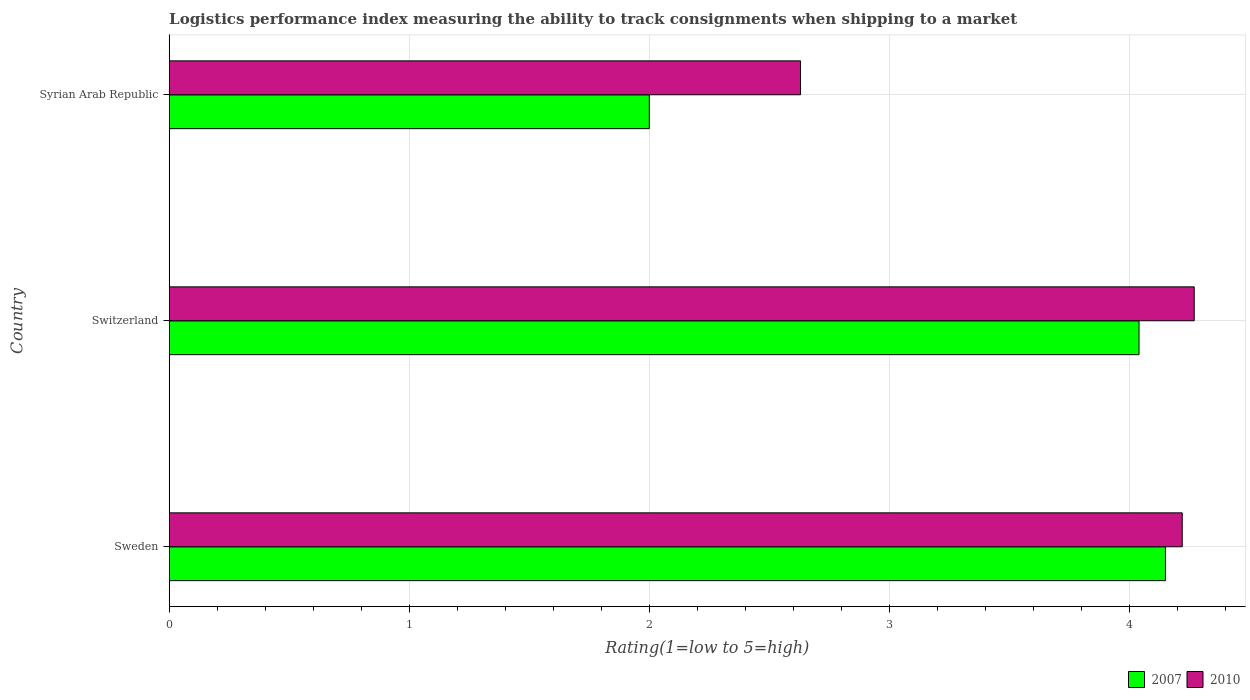How many groups of bars are there?
Your response must be concise. 3. Are the number of bars on each tick of the Y-axis equal?
Provide a succinct answer. Yes. How many bars are there on the 3rd tick from the top?
Provide a succinct answer. 2. How many bars are there on the 1st tick from the bottom?
Make the answer very short. 2. What is the label of the 3rd group of bars from the top?
Ensure brevity in your answer.  Sweden. Across all countries, what is the maximum Logistic performance index in 2010?
Your response must be concise. 4.27. Across all countries, what is the minimum Logistic performance index in 2007?
Provide a succinct answer. 2. In which country was the Logistic performance index in 2007 maximum?
Keep it short and to the point. Sweden. In which country was the Logistic performance index in 2007 minimum?
Your response must be concise. Syrian Arab Republic. What is the total Logistic performance index in 2010 in the graph?
Provide a succinct answer. 11.12. What is the difference between the Logistic performance index in 2007 in Sweden and that in Syrian Arab Republic?
Make the answer very short. 2.15. What is the difference between the Logistic performance index in 2010 in Syrian Arab Republic and the Logistic performance index in 2007 in Sweden?
Give a very brief answer. -1.52. What is the average Logistic performance index in 2010 per country?
Give a very brief answer. 3.71. What is the difference between the Logistic performance index in 2010 and Logistic performance index in 2007 in Syrian Arab Republic?
Your answer should be compact. 0.63. In how many countries, is the Logistic performance index in 2007 greater than 2.8 ?
Give a very brief answer. 2. What is the ratio of the Logistic performance index in 2010 in Switzerland to that in Syrian Arab Republic?
Your response must be concise. 1.62. Is the difference between the Logistic performance index in 2010 in Sweden and Syrian Arab Republic greater than the difference between the Logistic performance index in 2007 in Sweden and Syrian Arab Republic?
Offer a very short reply. No. What is the difference between the highest and the second highest Logistic performance index in 2010?
Give a very brief answer. 0.05. What is the difference between the highest and the lowest Logistic performance index in 2007?
Your answer should be very brief. 2.15. In how many countries, is the Logistic performance index in 2010 greater than the average Logistic performance index in 2010 taken over all countries?
Your answer should be compact. 2. Is the sum of the Logistic performance index in 2007 in Sweden and Syrian Arab Republic greater than the maximum Logistic performance index in 2010 across all countries?
Provide a succinct answer. Yes. What does the 1st bar from the top in Switzerland represents?
Your answer should be compact. 2010. What does the 2nd bar from the bottom in Syrian Arab Republic represents?
Make the answer very short. 2010. How many legend labels are there?
Provide a succinct answer. 2. What is the title of the graph?
Your answer should be very brief. Logistics performance index measuring the ability to track consignments when shipping to a market. What is the label or title of the X-axis?
Keep it short and to the point. Rating(1=low to 5=high). What is the label or title of the Y-axis?
Your response must be concise. Country. What is the Rating(1=low to 5=high) in 2007 in Sweden?
Keep it short and to the point. 4.15. What is the Rating(1=low to 5=high) in 2010 in Sweden?
Provide a succinct answer. 4.22. What is the Rating(1=low to 5=high) of 2007 in Switzerland?
Provide a succinct answer. 4.04. What is the Rating(1=low to 5=high) in 2010 in Switzerland?
Offer a very short reply. 4.27. What is the Rating(1=low to 5=high) in 2010 in Syrian Arab Republic?
Provide a short and direct response. 2.63. Across all countries, what is the maximum Rating(1=low to 5=high) in 2007?
Your response must be concise. 4.15. Across all countries, what is the maximum Rating(1=low to 5=high) of 2010?
Your response must be concise. 4.27. Across all countries, what is the minimum Rating(1=low to 5=high) of 2007?
Give a very brief answer. 2. Across all countries, what is the minimum Rating(1=low to 5=high) in 2010?
Offer a very short reply. 2.63. What is the total Rating(1=low to 5=high) of 2007 in the graph?
Offer a terse response. 10.19. What is the total Rating(1=low to 5=high) of 2010 in the graph?
Your response must be concise. 11.12. What is the difference between the Rating(1=low to 5=high) in 2007 in Sweden and that in Switzerland?
Provide a succinct answer. 0.11. What is the difference between the Rating(1=low to 5=high) in 2007 in Sweden and that in Syrian Arab Republic?
Keep it short and to the point. 2.15. What is the difference between the Rating(1=low to 5=high) in 2010 in Sweden and that in Syrian Arab Republic?
Provide a succinct answer. 1.59. What is the difference between the Rating(1=low to 5=high) of 2007 in Switzerland and that in Syrian Arab Republic?
Ensure brevity in your answer.  2.04. What is the difference between the Rating(1=low to 5=high) in 2010 in Switzerland and that in Syrian Arab Republic?
Make the answer very short. 1.64. What is the difference between the Rating(1=low to 5=high) of 2007 in Sweden and the Rating(1=low to 5=high) of 2010 in Switzerland?
Provide a short and direct response. -0.12. What is the difference between the Rating(1=low to 5=high) in 2007 in Sweden and the Rating(1=low to 5=high) in 2010 in Syrian Arab Republic?
Your answer should be very brief. 1.52. What is the difference between the Rating(1=low to 5=high) in 2007 in Switzerland and the Rating(1=low to 5=high) in 2010 in Syrian Arab Republic?
Your response must be concise. 1.41. What is the average Rating(1=low to 5=high) of 2007 per country?
Your response must be concise. 3.4. What is the average Rating(1=low to 5=high) in 2010 per country?
Make the answer very short. 3.71. What is the difference between the Rating(1=low to 5=high) in 2007 and Rating(1=low to 5=high) in 2010 in Sweden?
Ensure brevity in your answer.  -0.07. What is the difference between the Rating(1=low to 5=high) of 2007 and Rating(1=low to 5=high) of 2010 in Switzerland?
Ensure brevity in your answer.  -0.23. What is the difference between the Rating(1=low to 5=high) of 2007 and Rating(1=low to 5=high) of 2010 in Syrian Arab Republic?
Provide a short and direct response. -0.63. What is the ratio of the Rating(1=low to 5=high) of 2007 in Sweden to that in Switzerland?
Keep it short and to the point. 1.03. What is the ratio of the Rating(1=low to 5=high) in 2010 in Sweden to that in Switzerland?
Make the answer very short. 0.99. What is the ratio of the Rating(1=low to 5=high) in 2007 in Sweden to that in Syrian Arab Republic?
Keep it short and to the point. 2.08. What is the ratio of the Rating(1=low to 5=high) of 2010 in Sweden to that in Syrian Arab Republic?
Your response must be concise. 1.6. What is the ratio of the Rating(1=low to 5=high) in 2007 in Switzerland to that in Syrian Arab Republic?
Your answer should be compact. 2.02. What is the ratio of the Rating(1=low to 5=high) of 2010 in Switzerland to that in Syrian Arab Republic?
Offer a terse response. 1.62. What is the difference between the highest and the second highest Rating(1=low to 5=high) of 2007?
Provide a succinct answer. 0.11. What is the difference between the highest and the second highest Rating(1=low to 5=high) in 2010?
Ensure brevity in your answer.  0.05. What is the difference between the highest and the lowest Rating(1=low to 5=high) in 2007?
Give a very brief answer. 2.15. What is the difference between the highest and the lowest Rating(1=low to 5=high) in 2010?
Make the answer very short. 1.64. 